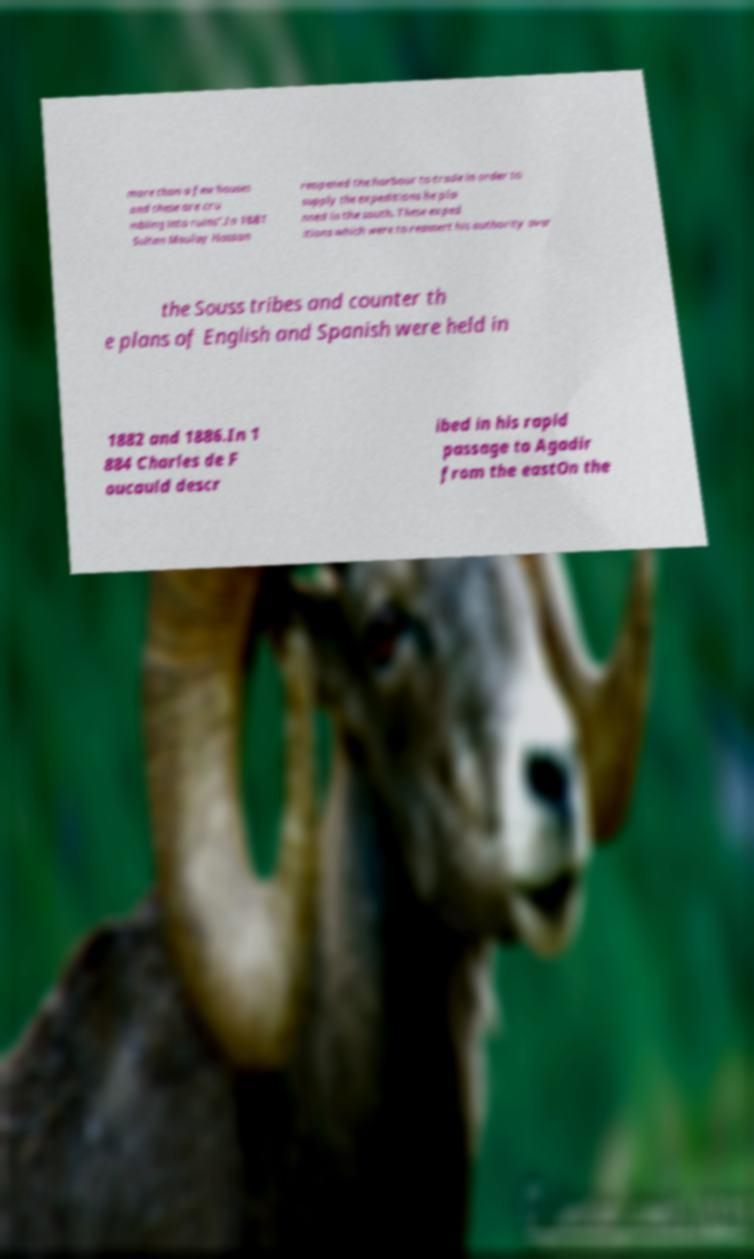Please read and relay the text visible in this image. What does it say? more than a few houses and these are cru mbling into ruins".In 1881 Sultan Moulay Hassan reopened the harbour to trade in order to supply the expeditions he pla nned in the south. These exped itions which were to reassert his authority over the Souss tribes and counter th e plans of English and Spanish were held in 1882 and 1886.In 1 884 Charles de F oucauld descr ibed in his rapid passage to Agadir from the eastOn the 